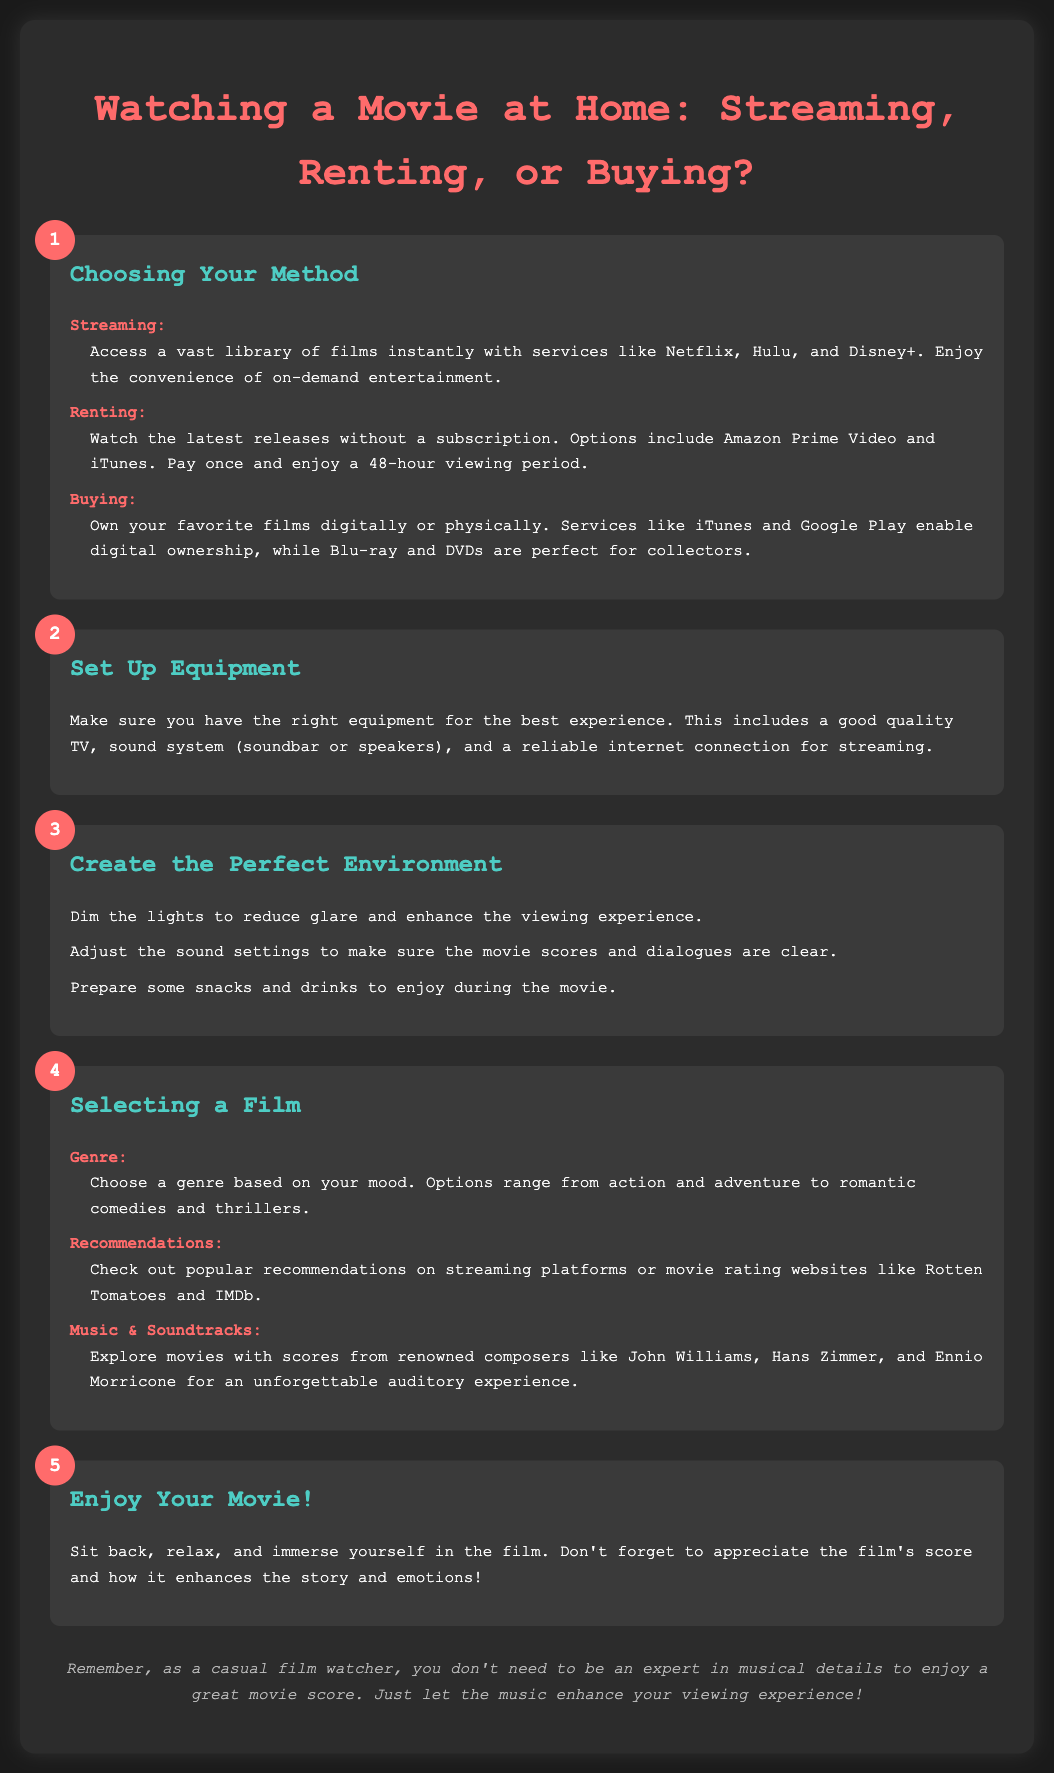what is the title of the document? The title is prominently displayed at the top of the infographic, highlighting the main focus of the content.
Answer: Watching a Movie at Home: Streaming, Renting, or Buying? how many methods of watching a movie at home are listed? The document outlines three distinct methods of watching a movie at home.
Answer: 3 what is one streaming service mentioned in the document? The document provides specific examples of streaming services in the first section about choosing methods.
Answer: Netflix what should you do to set up equipment for watching a movie? The document specifies the need for certain equipment to ensure a good viewing experience in the second step.
Answer: Good quality TV what genre options are suggested for selecting a film? The document lists options related to film genres that viewers can choose from when selecting a movie.
Answer: Action and adventure which composers are noted for their scores in the selection criteria? The document identifies specific renowned composers known for their impactful scores in movies.
Answer: John Williams, Hans Zimmer, and Ennio Morricone what is the key advice before enjoying the movie? The final step emphasizes an important aspect to remember while watching.
Answer: Appreciate the film's score how can you enhance your viewing environment? The document mentions specific actions that can improve the viewing experience, making it more enjoyable.
Answer: Dim the lights what is the purpose of this infographic? The overall goal of the infographic is suggested through its layout and content focusing on movie watching methods.
Answer: To guide movie watching at home 